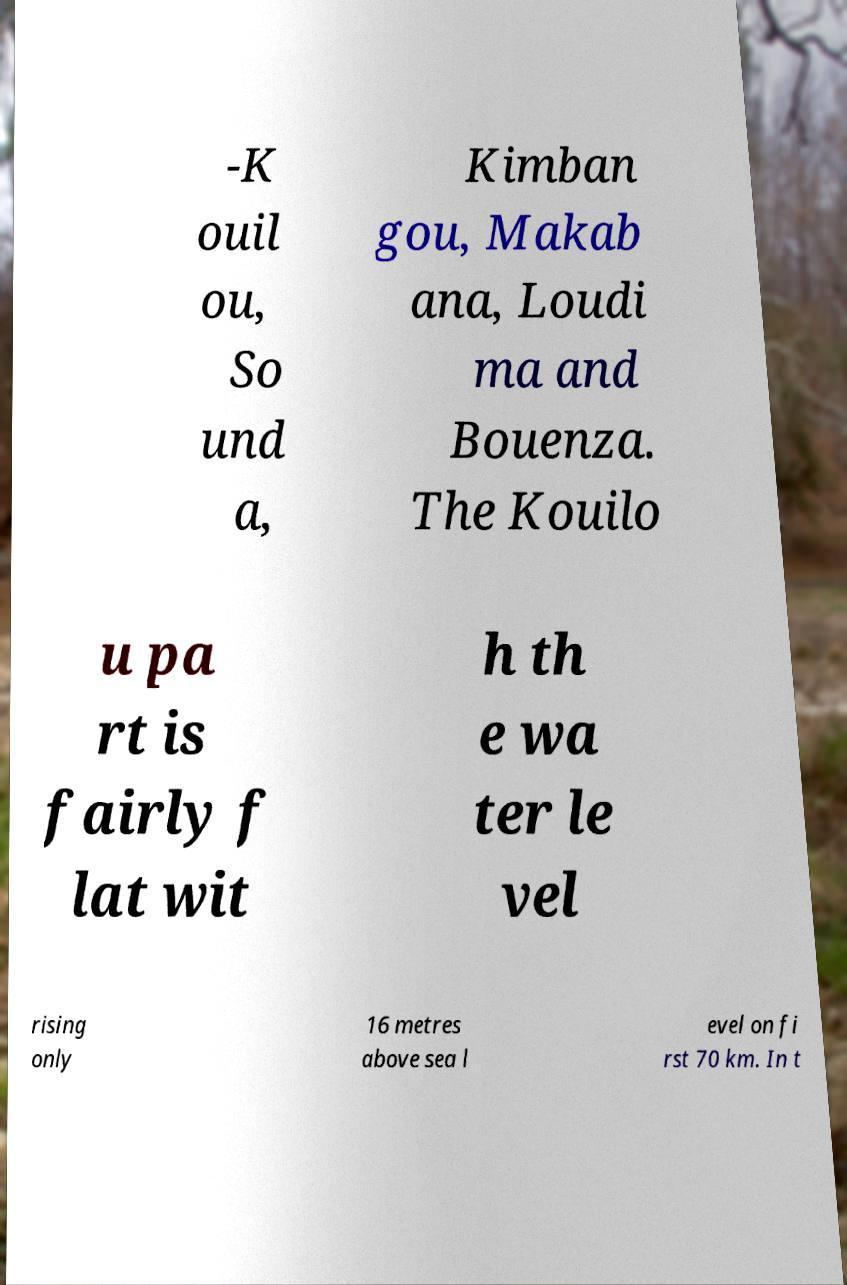For documentation purposes, I need the text within this image transcribed. Could you provide that? -K ouil ou, So und a, Kimban gou, Makab ana, Loudi ma and Bouenza. The Kouilo u pa rt is fairly f lat wit h th e wa ter le vel rising only 16 metres above sea l evel on fi rst 70 km. In t 